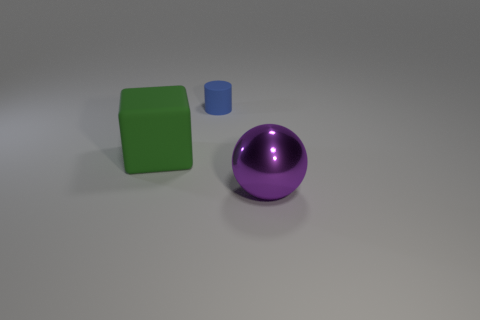Is there anything else that is made of the same material as the big ball?
Give a very brief answer. No. Is there anything else that is the same size as the blue cylinder?
Your answer should be very brief. No. There is a large green object; is it the same shape as the thing that is behind the big block?
Offer a very short reply. No. There is a thing that is on the left side of the purple metallic sphere and right of the big cube; what is its shape?
Your answer should be very brief. Cylinder. Are there the same number of large purple spheres that are to the left of the blue cylinder and big purple shiny objects that are in front of the large ball?
Make the answer very short. Yes. How many green things are either large metallic cylinders or large matte cubes?
Keep it short and to the point. 1. What shape is the object right of the tiny blue cylinder?
Provide a succinct answer. Sphere. Is there a blue cylinder made of the same material as the green object?
Give a very brief answer. Yes. Is the purple metallic ball the same size as the matte cylinder?
Give a very brief answer. No. How many balls are metal things or small matte objects?
Offer a very short reply. 1. 